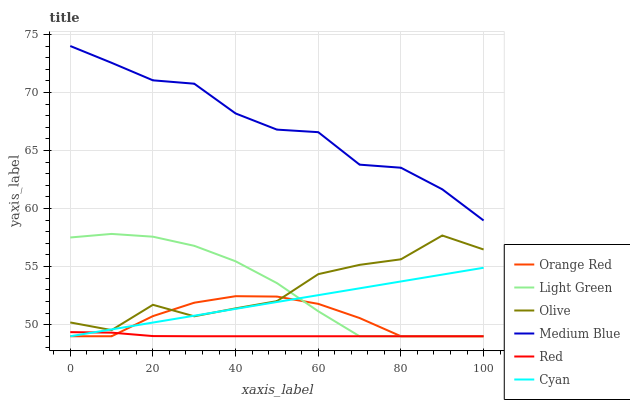Does Red have the minimum area under the curve?
Answer yes or no. Yes. Does Medium Blue have the maximum area under the curve?
Answer yes or no. Yes. Does Light Green have the minimum area under the curve?
Answer yes or no. No. Does Light Green have the maximum area under the curve?
Answer yes or no. No. Is Cyan the smoothest?
Answer yes or no. Yes. Is Olive the roughest?
Answer yes or no. Yes. Is Light Green the smoothest?
Answer yes or no. No. Is Light Green the roughest?
Answer yes or no. No. Does Light Green have the lowest value?
Answer yes or no. Yes. Does Olive have the lowest value?
Answer yes or no. No. Does Medium Blue have the highest value?
Answer yes or no. Yes. Does Light Green have the highest value?
Answer yes or no. No. Is Red less than Olive?
Answer yes or no. Yes. Is Medium Blue greater than Olive?
Answer yes or no. Yes. Does Olive intersect Cyan?
Answer yes or no. Yes. Is Olive less than Cyan?
Answer yes or no. No. Is Olive greater than Cyan?
Answer yes or no. No. Does Red intersect Olive?
Answer yes or no. No. 